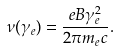Convert formula to latex. <formula><loc_0><loc_0><loc_500><loc_500>\nu ( \gamma _ { e } ) = \frac { e B \gamma _ { e } ^ { 2 } } { 2 \pi m _ { e } c } .</formula> 